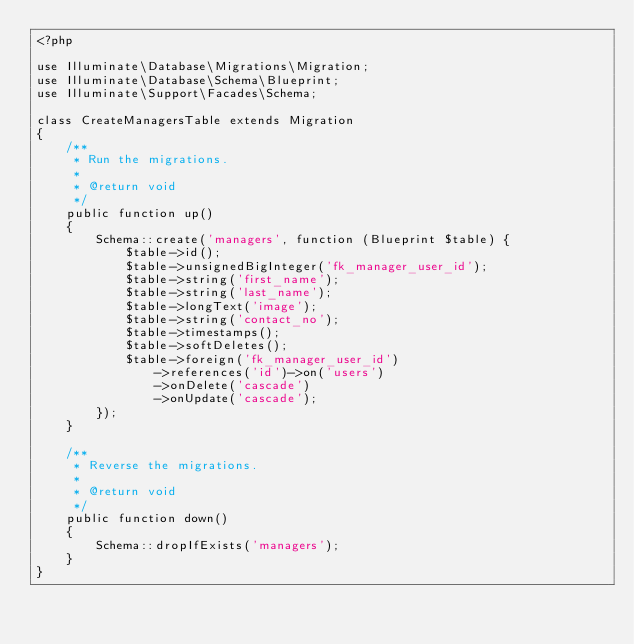<code> <loc_0><loc_0><loc_500><loc_500><_PHP_><?php

use Illuminate\Database\Migrations\Migration;
use Illuminate\Database\Schema\Blueprint;
use Illuminate\Support\Facades\Schema;

class CreateManagersTable extends Migration
{
    /**
     * Run the migrations.
     *
     * @return void
     */
    public function up()
    {
        Schema::create('managers', function (Blueprint $table) {
            $table->id();
            $table->unsignedBigInteger('fk_manager_user_id');
            $table->string('first_name');
            $table->string('last_name');
            $table->longText('image');
            $table->string('contact_no');
            $table->timestamps();
            $table->softDeletes();
            $table->foreign('fk_manager_user_id')
                ->references('id')->on('users')
                ->onDelete('cascade')
                ->onUpdate('cascade');
        });
    }

    /**
     * Reverse the migrations.
     *
     * @return void
     */
    public function down()
    {
        Schema::dropIfExists('managers');
    }
}
</code> 